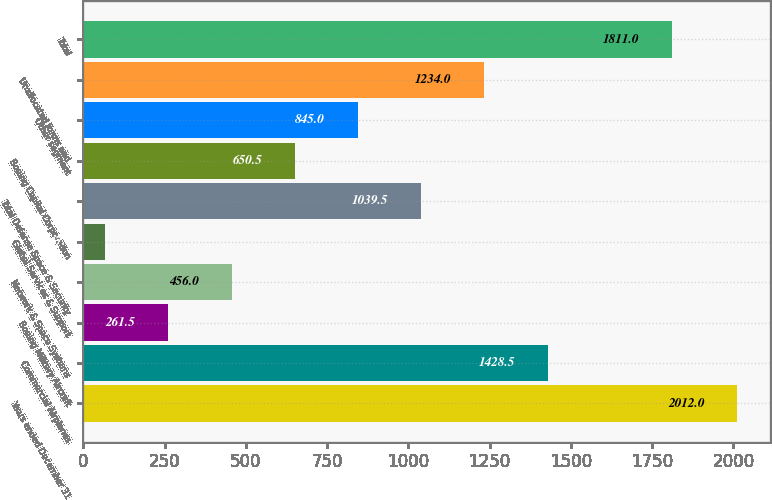Convert chart to OTSL. <chart><loc_0><loc_0><loc_500><loc_500><bar_chart><fcel>Years ended December 31<fcel>Commercial Airplanes<fcel>Boeing Military Aircraft<fcel>Network & Space Systems<fcel>Global Services & Support<fcel>Total Defense Space & Security<fcel>Boeing Capital Corporation<fcel>Other segment<fcel>Unallocated items and<fcel>Total<nl><fcel>2012<fcel>1428.5<fcel>261.5<fcel>456<fcel>67<fcel>1039.5<fcel>650.5<fcel>845<fcel>1234<fcel>1811<nl></chart> 